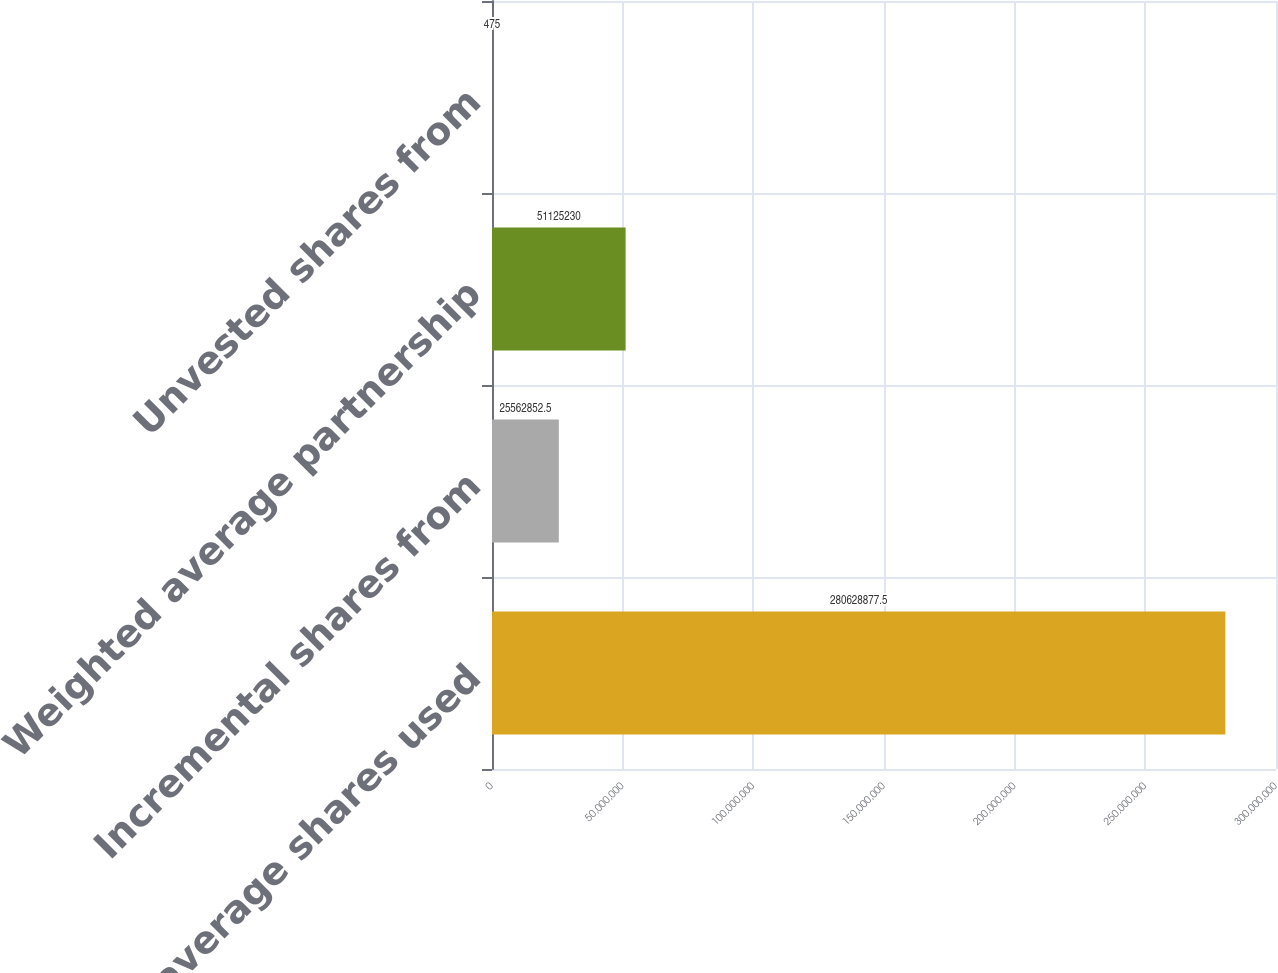Convert chart to OTSL. <chart><loc_0><loc_0><loc_500><loc_500><bar_chart><fcel>Weighted average shares used<fcel>Incremental shares from<fcel>Weighted average partnership<fcel>Unvested shares from<nl><fcel>2.80629e+08<fcel>2.55629e+07<fcel>5.11252e+07<fcel>475<nl></chart> 